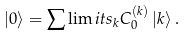<formula> <loc_0><loc_0><loc_500><loc_500>\left | 0 \right \rangle = \sum \lim i t s _ { k } C _ { 0 } ^ { ( k ) } \left | k \right \rangle .</formula> 